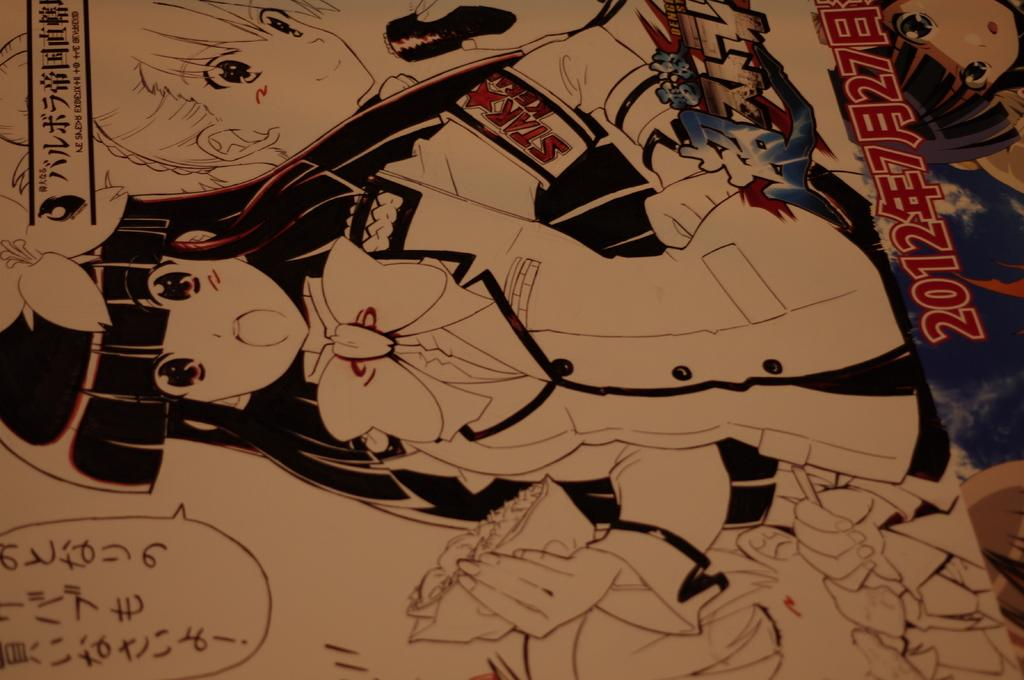What type of image is depicted in the cartoon poster? The image is a cartoon poster. Who is the main character in the poster? There is a girl in the poster. What additional information can be found at the bottom of the poster? There is text at the bottom of the poster. How many fish are swimming in the background of the poster? There are no fish visible in the poster; it is a cartoon poster featuring a girl. What song is the girl singing in the poster? There is no indication of the girl singing in the poster, nor is there any mention of a song. 